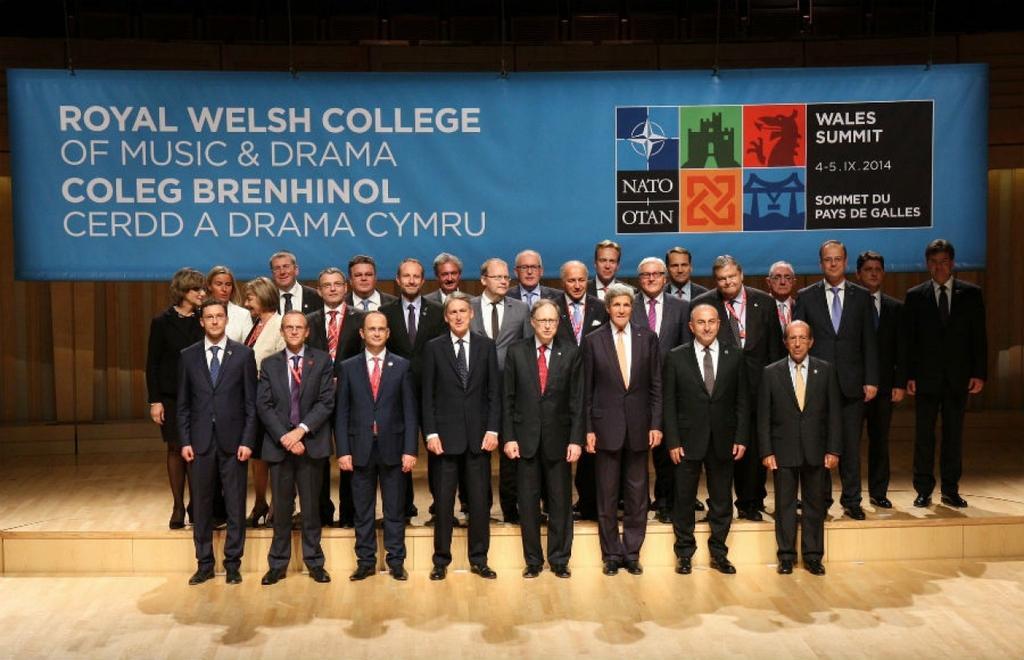In one or two sentences, can you explain what this image depicts? In this picture I can observe some people standing on the floor. They are wearing coats. In the background I can observe blue color flex. 